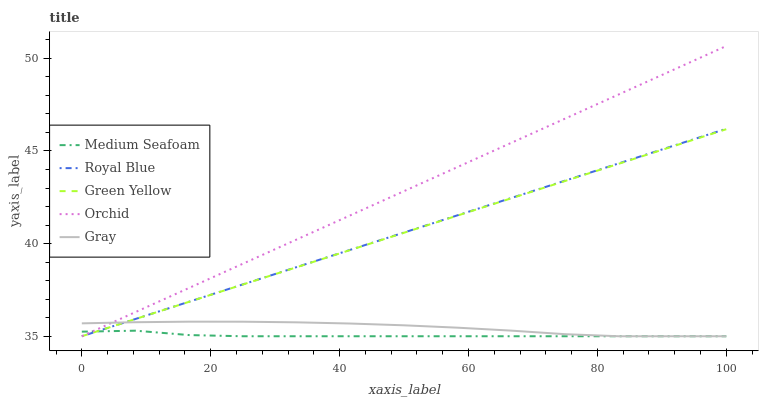Does Medium Seafoam have the minimum area under the curve?
Answer yes or no. Yes. Does Orchid have the maximum area under the curve?
Answer yes or no. Yes. Does Gray have the minimum area under the curve?
Answer yes or no. No. Does Gray have the maximum area under the curve?
Answer yes or no. No. Is Green Yellow the smoothest?
Answer yes or no. Yes. Is Medium Seafoam the roughest?
Answer yes or no. Yes. Is Gray the smoothest?
Answer yes or no. No. Is Gray the roughest?
Answer yes or no. No. Does Royal Blue have the lowest value?
Answer yes or no. Yes. Does Orchid have the highest value?
Answer yes or no. Yes. Does Gray have the highest value?
Answer yes or no. No. Does Gray intersect Green Yellow?
Answer yes or no. Yes. Is Gray less than Green Yellow?
Answer yes or no. No. Is Gray greater than Green Yellow?
Answer yes or no. No. 